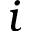Convert formula to latex. <formula><loc_0><loc_0><loc_500><loc_500>i</formula> 